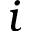Convert formula to latex. <formula><loc_0><loc_0><loc_500><loc_500>i</formula> 